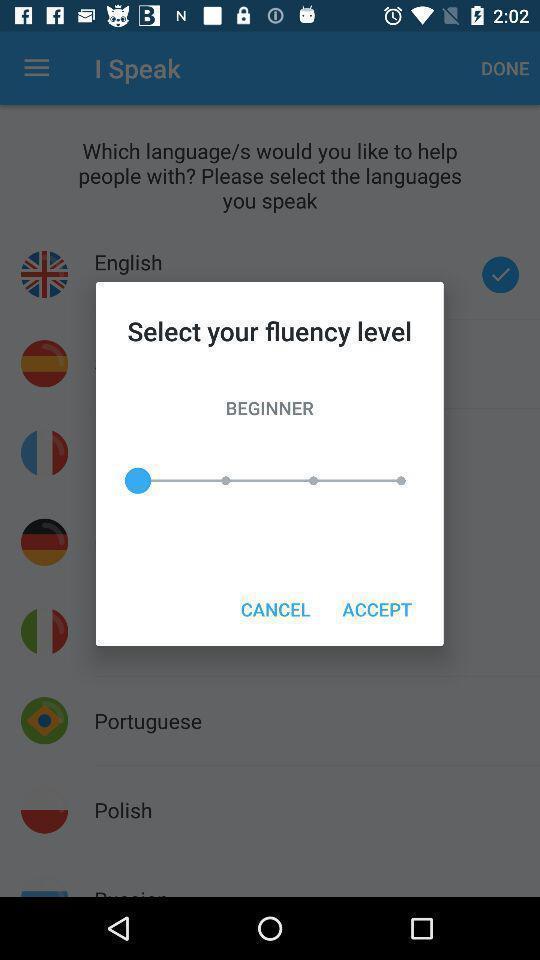Tell me what you see in this picture. Pop-up asking to select fluency level. 